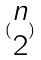<formula> <loc_0><loc_0><loc_500><loc_500>( \begin{matrix} n \\ 2 \end{matrix} )</formula> 